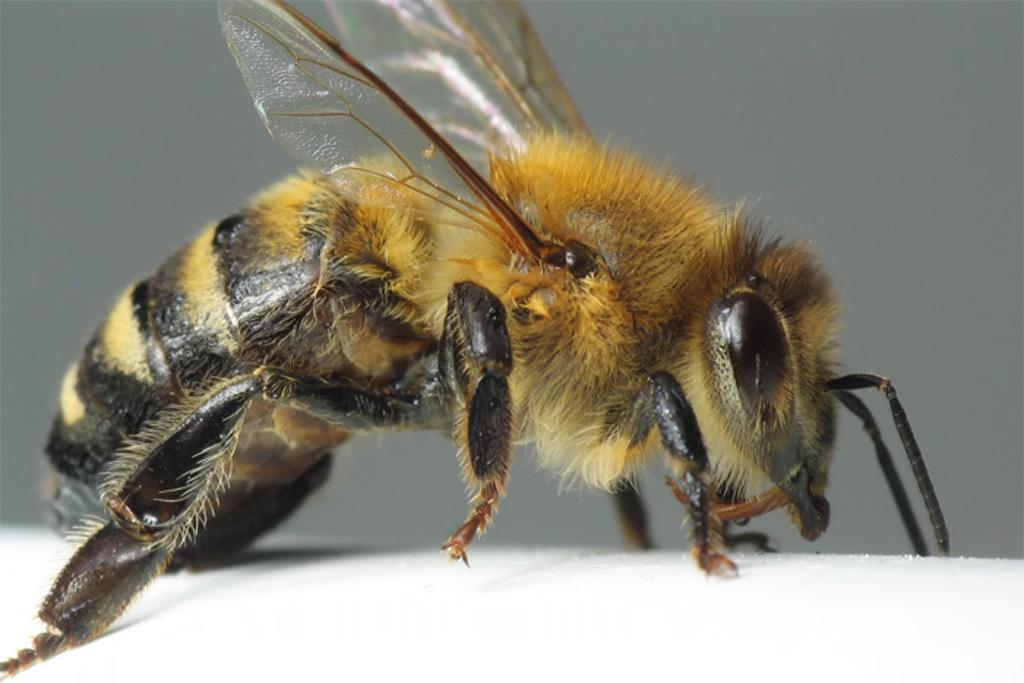What type of insect is present in the image? There is a honeybee in the image. What type of lock is the honeybee trying to open in the image? There is no lock present in the image; it features a honeybee. What type of bird can be seen flying alongside the honeybee in the image? There is no bird present in the image; it features a honeybee. 